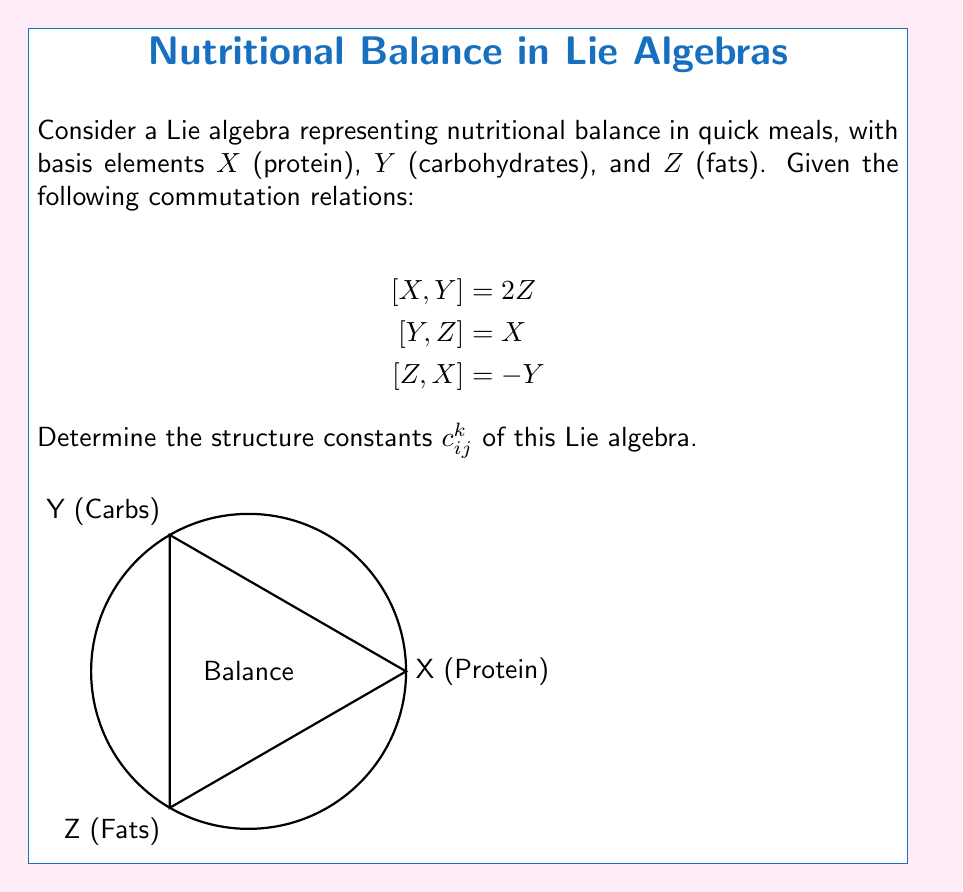Provide a solution to this math problem. Let's approach this step-by-step:

1) The structure constants $c_{ij}^k$ are defined by the equation:

   $$[X_i, X_j] = \sum_k c_{ij}^k X_k$$

2) From the given commutation relations, we can identify:

   $[X,Y] = 2Z$ implies $c_{12}^3 = 2$ and $c_{21}^3 = -2$
   $[Y,Z] = X$ implies $c_{23}^1 = 1$ and $c_{32}^1 = -1$
   $[Z,X] = -Y$ implies $c_{31}^2 = -1$ and $c_{13}^2 = 1$

3) All other structure constants are zero.

4) We can represent these in a 3x3x3 array where $c_{ij}^k$ is the $(i,j,k)$ element:

   $$c_{ij}^1 = \begin{pmatrix}
   0 & 0 & -1 \\
   0 & 0 & 1 \\
   1 & -1 & 0
   \end{pmatrix}$$

   $$c_{ij}^2 = \begin{pmatrix}
   0 & -1 & 0 \\
   1 & 0 & 0 \\
   0 & 0 & 0
   \end{pmatrix}$$

   $$c_{ij}^3 = \begin{pmatrix}
   0 & 2 & 0 \\
   -2 & 0 & 0 \\
   0 & 0 & 0
   \end{pmatrix}$$

5) These structure constants satisfy the Jacobi identity:

   $$c_{ij}^m c_{mk}^l + c_{jk}^m c_{mi}^l + c_{ki}^m c_{mj}^l = 0$$

   for all $i,j,k,l$, which confirms that this is indeed a valid Lie algebra.
Answer: $c_{12}^3 = 2$, $c_{21}^3 = -2$, $c_{23}^1 = 1$, $c_{32}^1 = -1$, $c_{31}^2 = -1$, $c_{13}^2 = 1$, all others zero. 